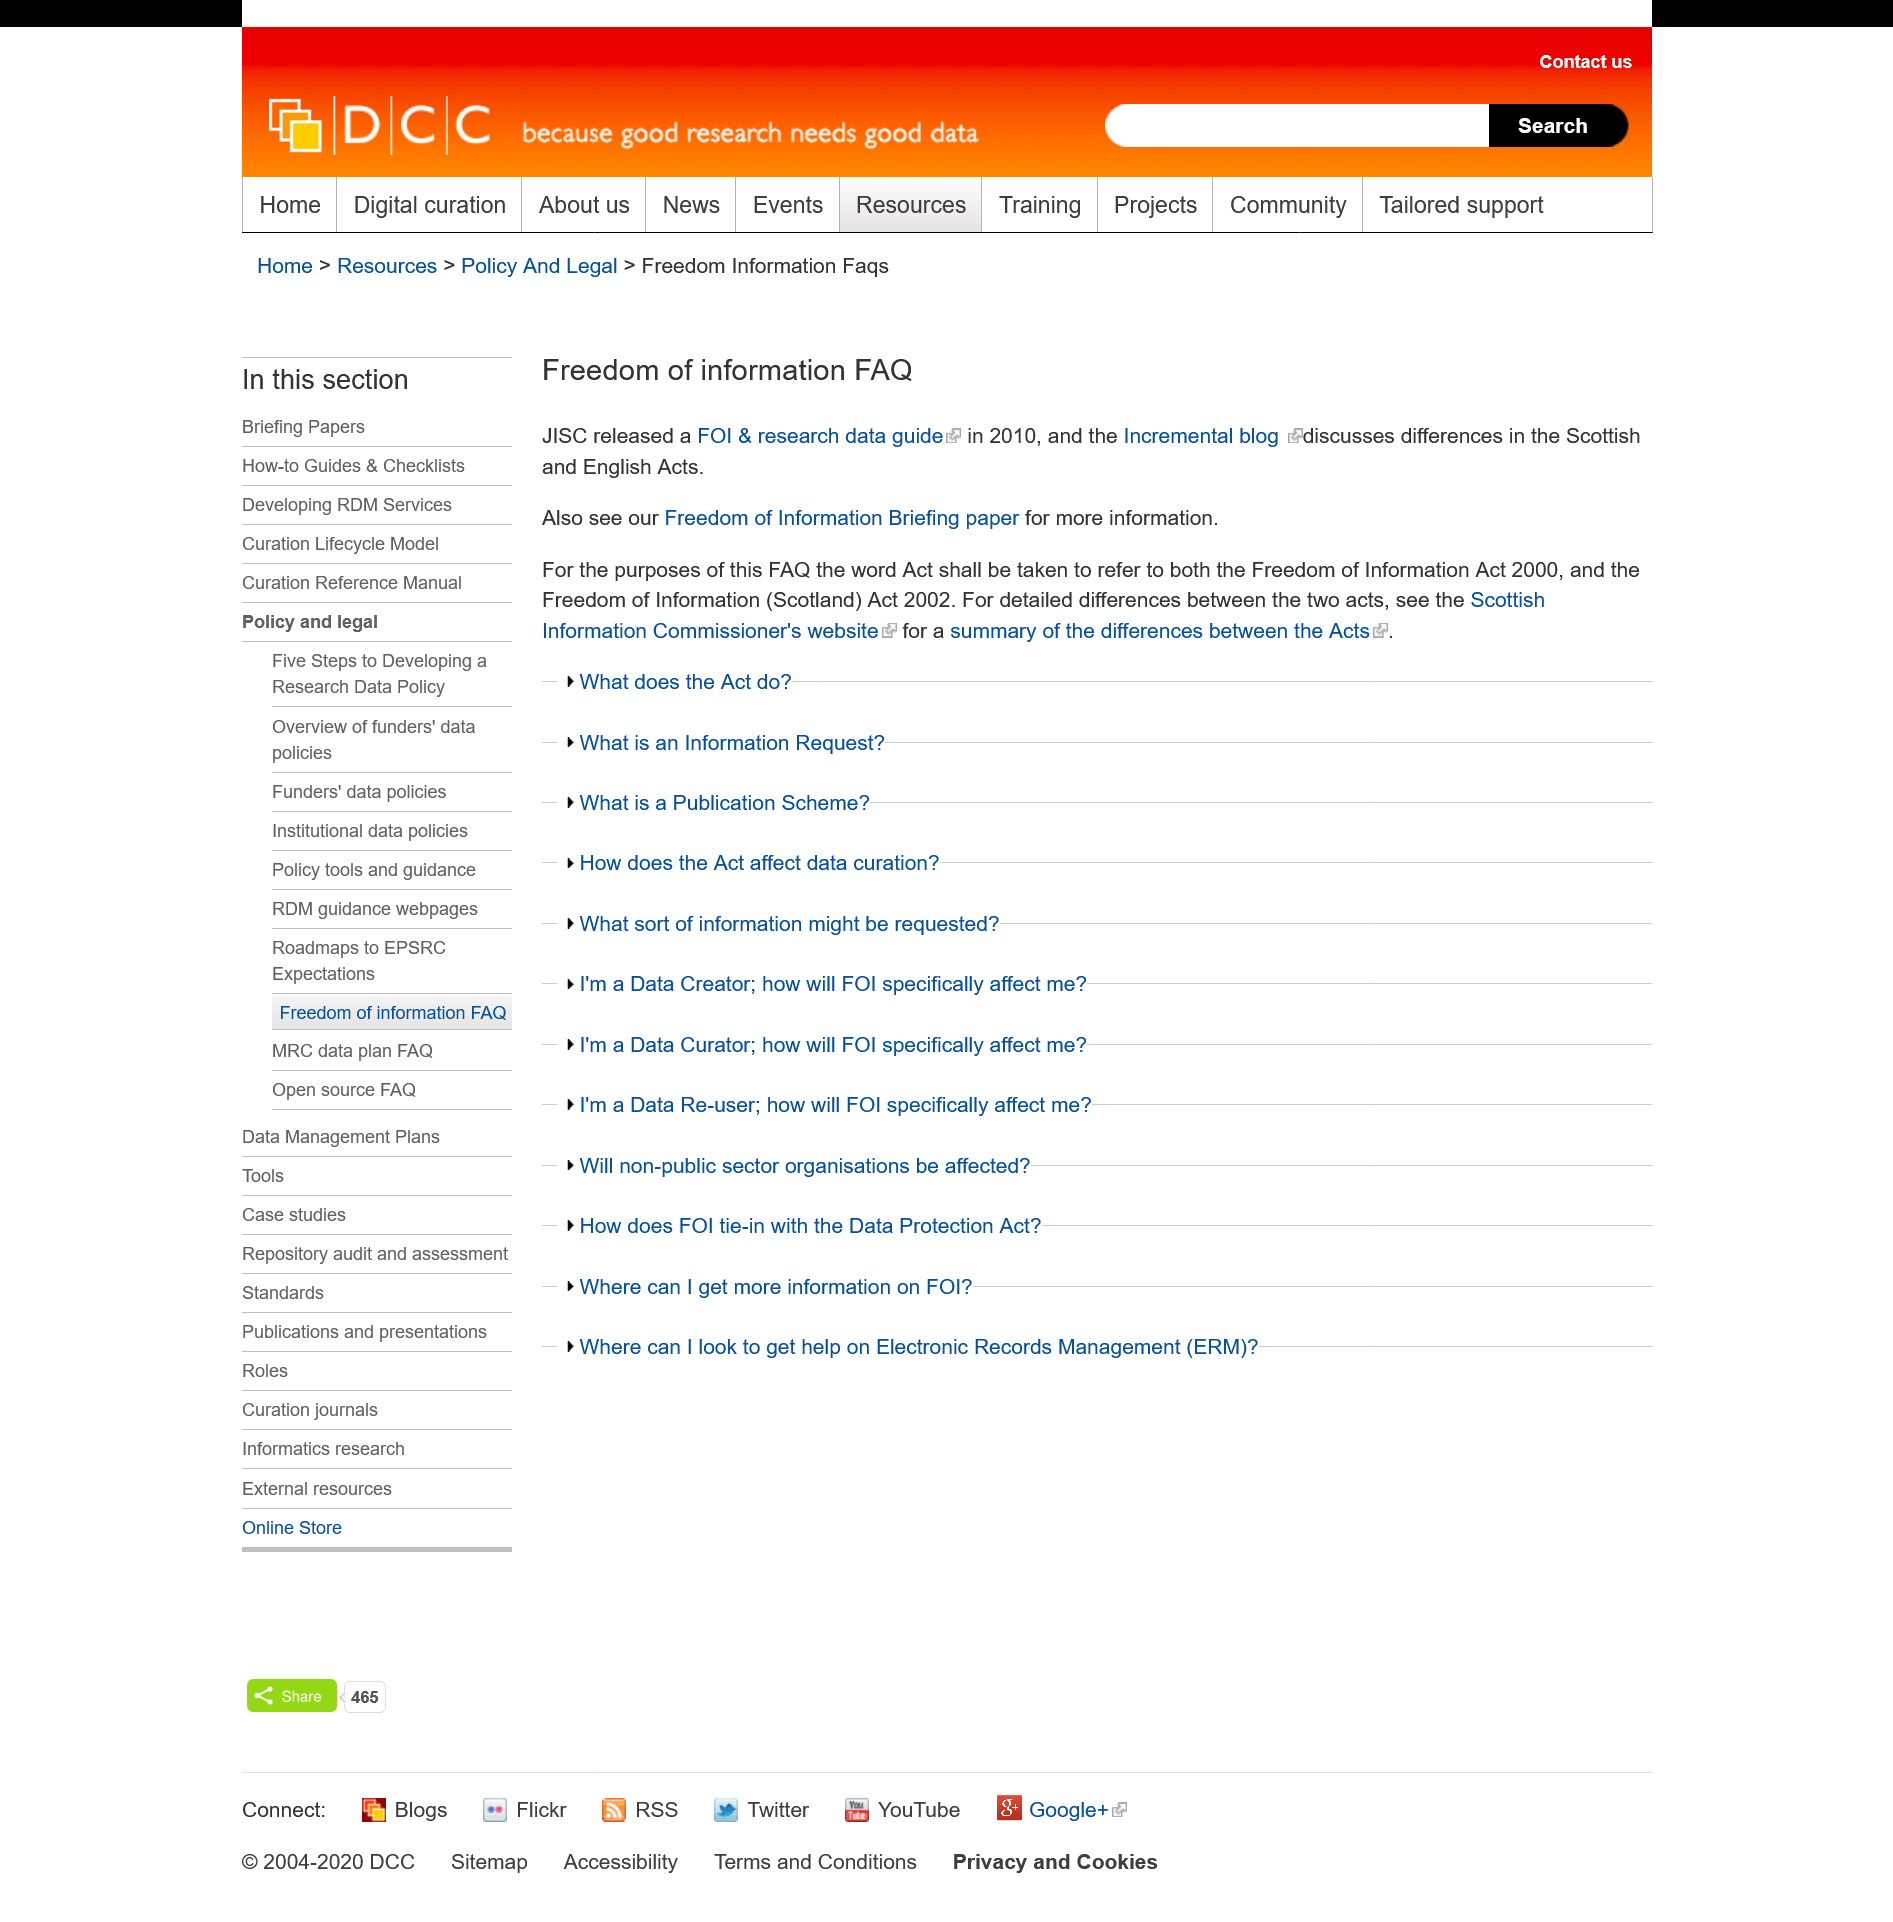Indicate a few pertinent items in this graphic. The Incremental blog discusses the Freedom of Information (Scotland) Act 2002, and it does so. The FOI & research data guide was released in 2010. The JISC released a FOI and research data guide. 